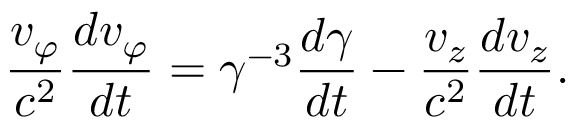Convert formula to latex. <formula><loc_0><loc_0><loc_500><loc_500>\frac { v _ { \varphi } } { c ^ { 2 } } \frac { d v _ { \varphi } } { d t } = \gamma ^ { - 3 } \frac { d \gamma } { d t } - \frac { v _ { z } } { c ^ { 2 } } \frac { d v _ { z } } { d t } .</formula> 